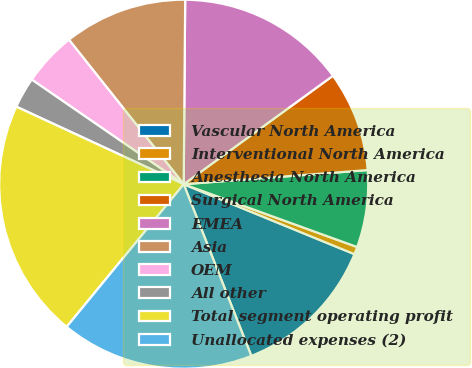Convert chart to OTSL. <chart><loc_0><loc_0><loc_500><loc_500><pie_chart><fcel>Vascular North America<fcel>Interventional North America<fcel>Anesthesia North America<fcel>Surgical North America<fcel>EMEA<fcel>Asia<fcel>OEM<fcel>All other<fcel>Total segment operating profit<fcel>Unallocated expenses (2)<nl><fcel>12.84%<fcel>0.66%<fcel>6.75%<fcel>8.78%<fcel>14.87%<fcel>10.81%<fcel>4.72%<fcel>2.69%<fcel>20.97%<fcel>16.91%<nl></chart> 